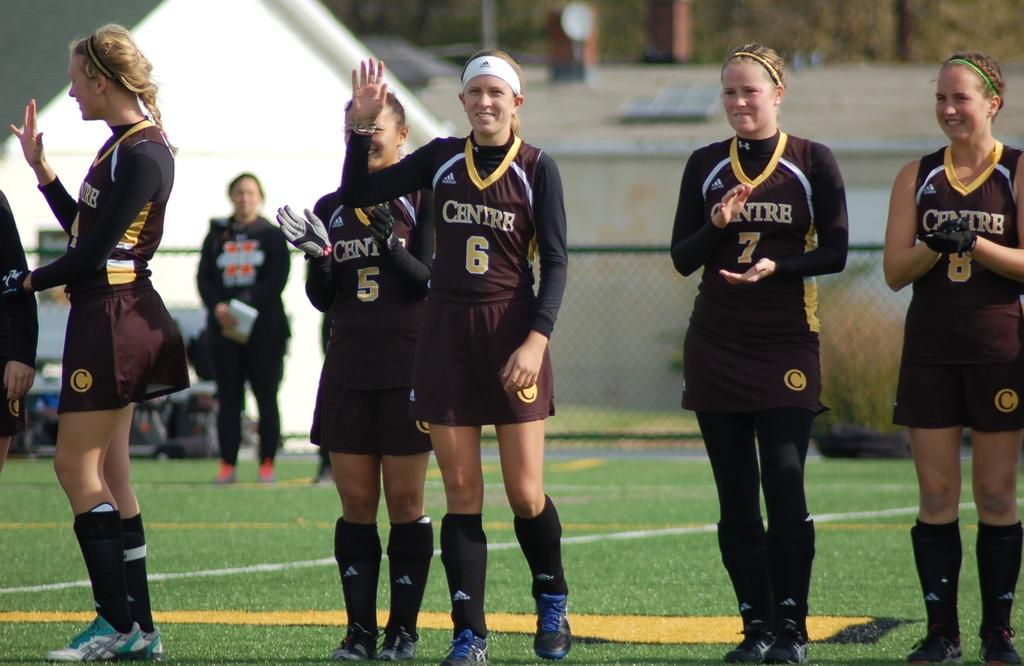<image>
Summarize the visual content of the image. A girl stand on a field in a black uniform with the number 6 on it. 